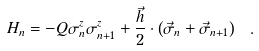<formula> <loc_0><loc_0><loc_500><loc_500>H _ { n } = - Q \sigma ^ { z } _ { n } \sigma ^ { z } _ { n + 1 } + \frac { \vec { h } } { 2 } \cdot \left ( \vec { \sigma } _ { n } + \vec { \sigma } _ { n + 1 } \right ) \ .</formula> 